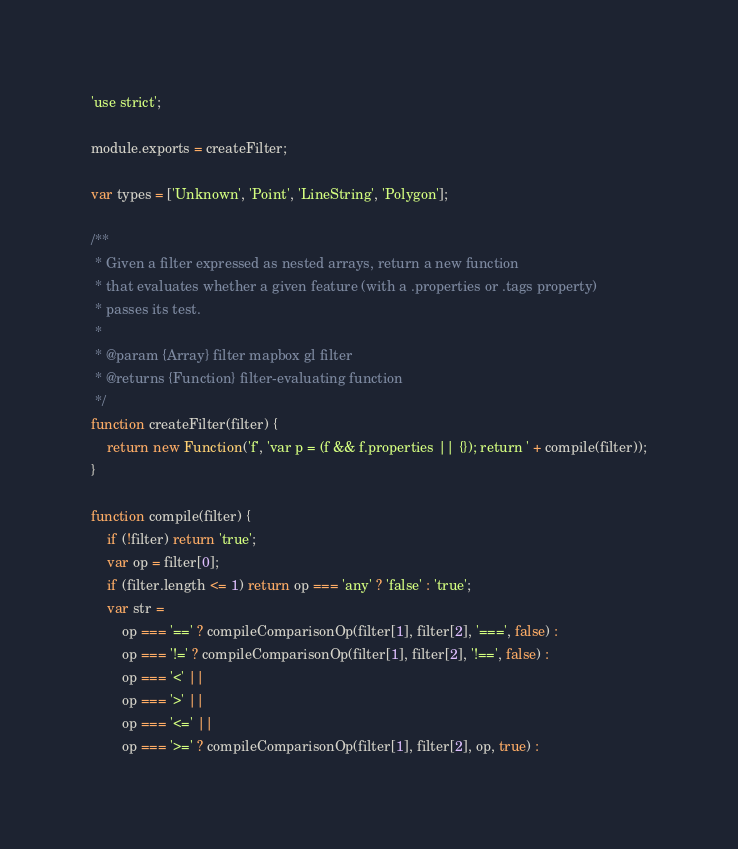Convert code to text. <code><loc_0><loc_0><loc_500><loc_500><_JavaScript_>'use strict';

module.exports = createFilter;

var types = ['Unknown', 'Point', 'LineString', 'Polygon'];

/**
 * Given a filter expressed as nested arrays, return a new function
 * that evaluates whether a given feature (with a .properties or .tags property)
 * passes its test.
 *
 * @param {Array} filter mapbox gl filter
 * @returns {Function} filter-evaluating function
 */
function createFilter(filter) {
    return new Function('f', 'var p = (f && f.properties || {}); return ' + compile(filter));
}

function compile(filter) {
    if (!filter) return 'true';
    var op = filter[0];
    if (filter.length <= 1) return op === 'any' ? 'false' : 'true';
    var str =
        op === '==' ? compileComparisonOp(filter[1], filter[2], '===', false) :
        op === '!=' ? compileComparisonOp(filter[1], filter[2], '!==', false) :
        op === '<' ||
        op === '>' ||
        op === '<=' ||
        op === '>=' ? compileComparisonOp(filter[1], filter[2], op, true) :</code> 